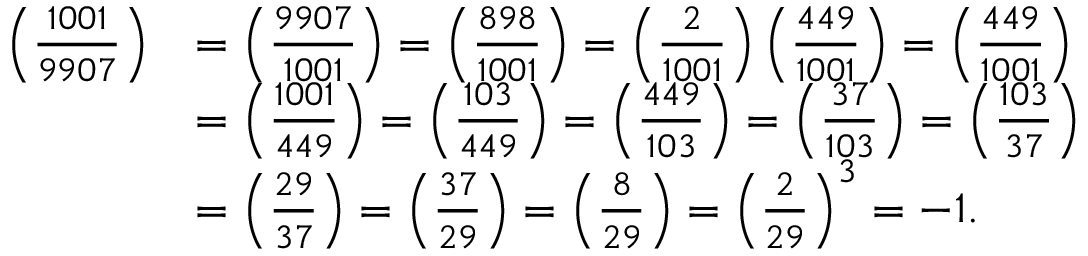Convert formula to latex. <formula><loc_0><loc_0><loc_500><loc_500>{ \begin{array} { r l } { \left ( { \frac { 1 0 0 1 } { 9 9 0 7 } } \right ) } & { = \left ( { \frac { 9 9 0 7 } { 1 0 0 1 } } \right ) = \left ( { \frac { 8 9 8 } { 1 0 0 1 } } \right ) = \left ( { \frac { 2 } { 1 0 0 1 } } \right ) \left ( { \frac { 4 4 9 } { 1 0 0 1 } } \right ) = \left ( { \frac { 4 4 9 } { 1 0 0 1 } } \right ) } \\ & { = \left ( { \frac { 1 0 0 1 } { 4 4 9 } } \right ) = \left ( { \frac { 1 0 3 } { 4 4 9 } } \right ) = \left ( { \frac { 4 4 9 } { 1 0 3 } } \right ) = \left ( { \frac { 3 7 } { 1 0 3 } } \right ) = \left ( { \frac { 1 0 3 } { 3 7 } } \right ) } \\ & { = \left ( { \frac { 2 9 } { 3 7 } } \right ) = \left ( { \frac { 3 7 } { 2 9 } } \right ) = \left ( { \frac { 8 } { 2 9 } } \right ) = \left ( { \frac { 2 } { 2 9 } } \right ) ^ { 3 } = - 1 . } \end{array} }</formula> 